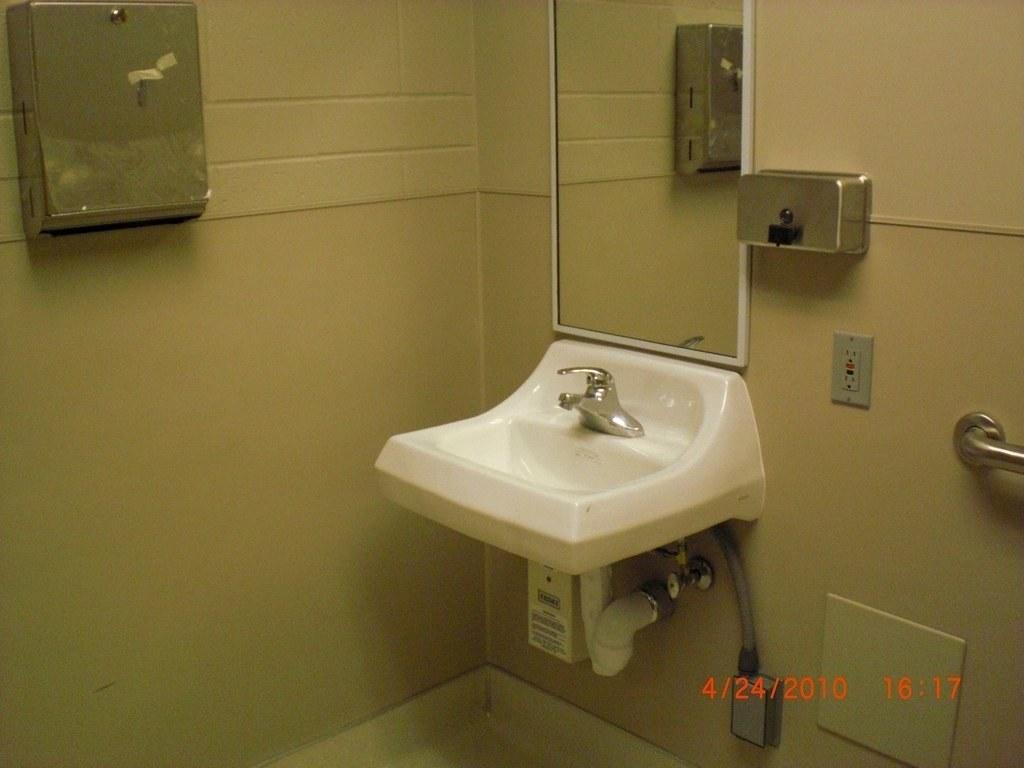Please provide a concise description of this image. There is a white color sink and a mirror is attached to the wall as we can see on the right side of this image. There is an object attached to the wall at the top left side of this image. 